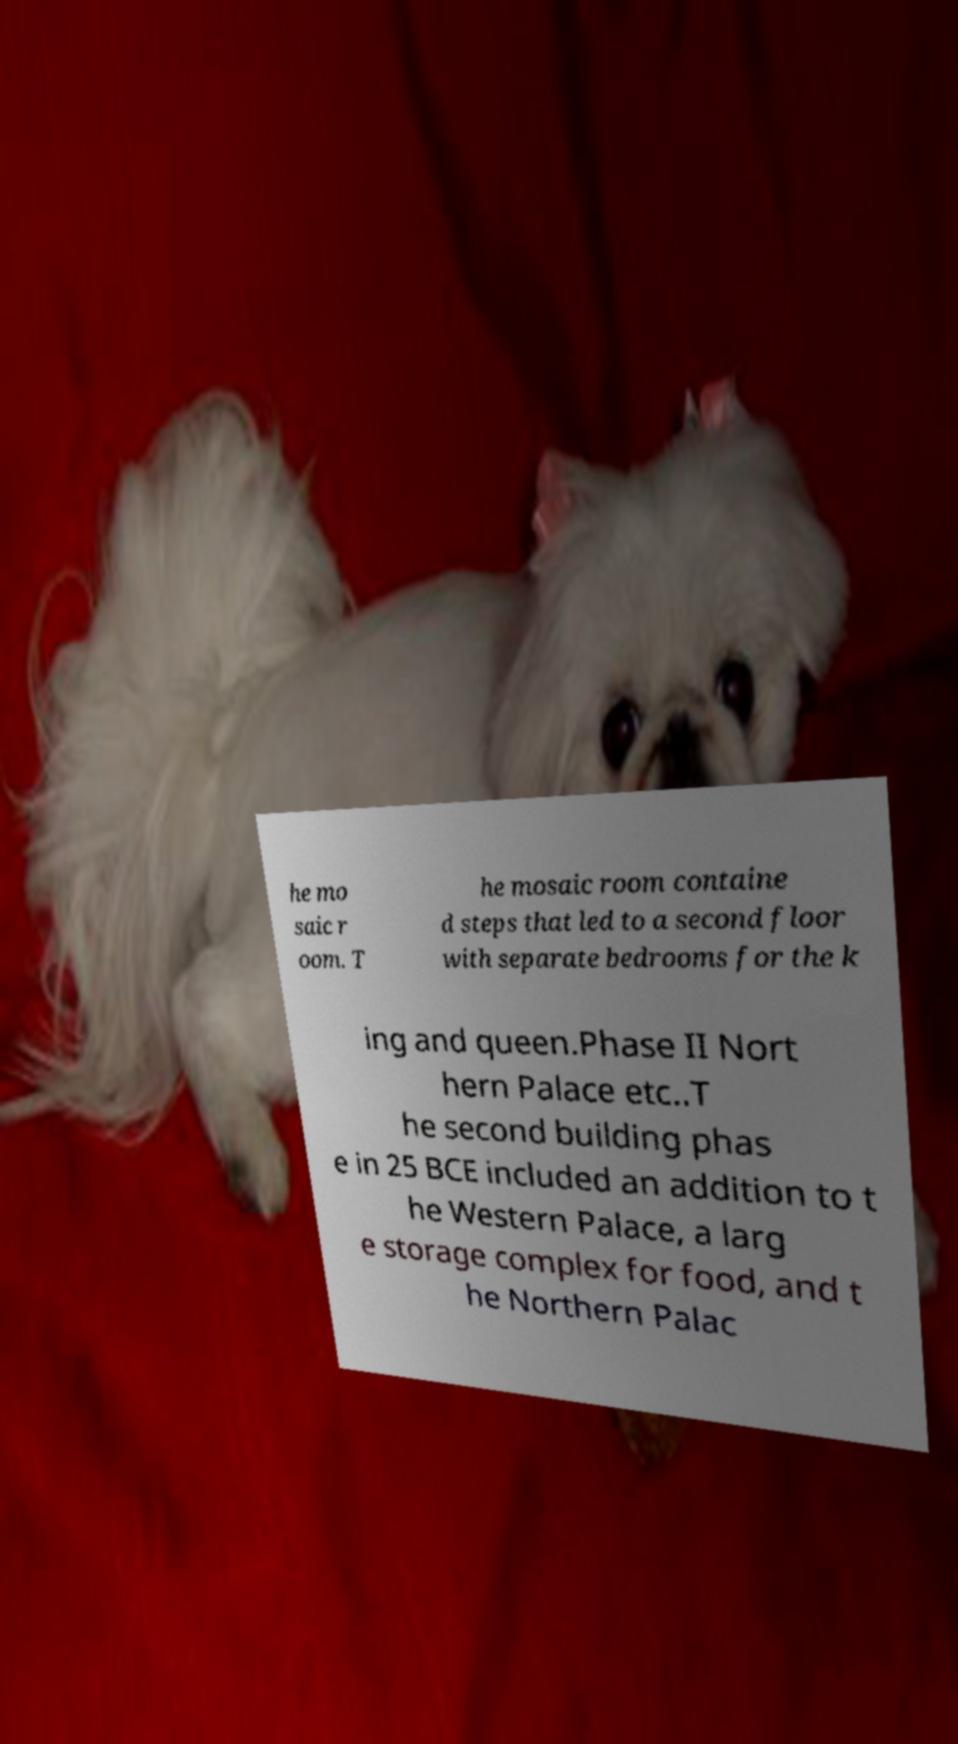Could you assist in decoding the text presented in this image and type it out clearly? he mo saic r oom. T he mosaic room containe d steps that led to a second floor with separate bedrooms for the k ing and queen.Phase II Nort hern Palace etc..T he second building phas e in 25 BCE included an addition to t he Western Palace, a larg e storage complex for food, and t he Northern Palac 